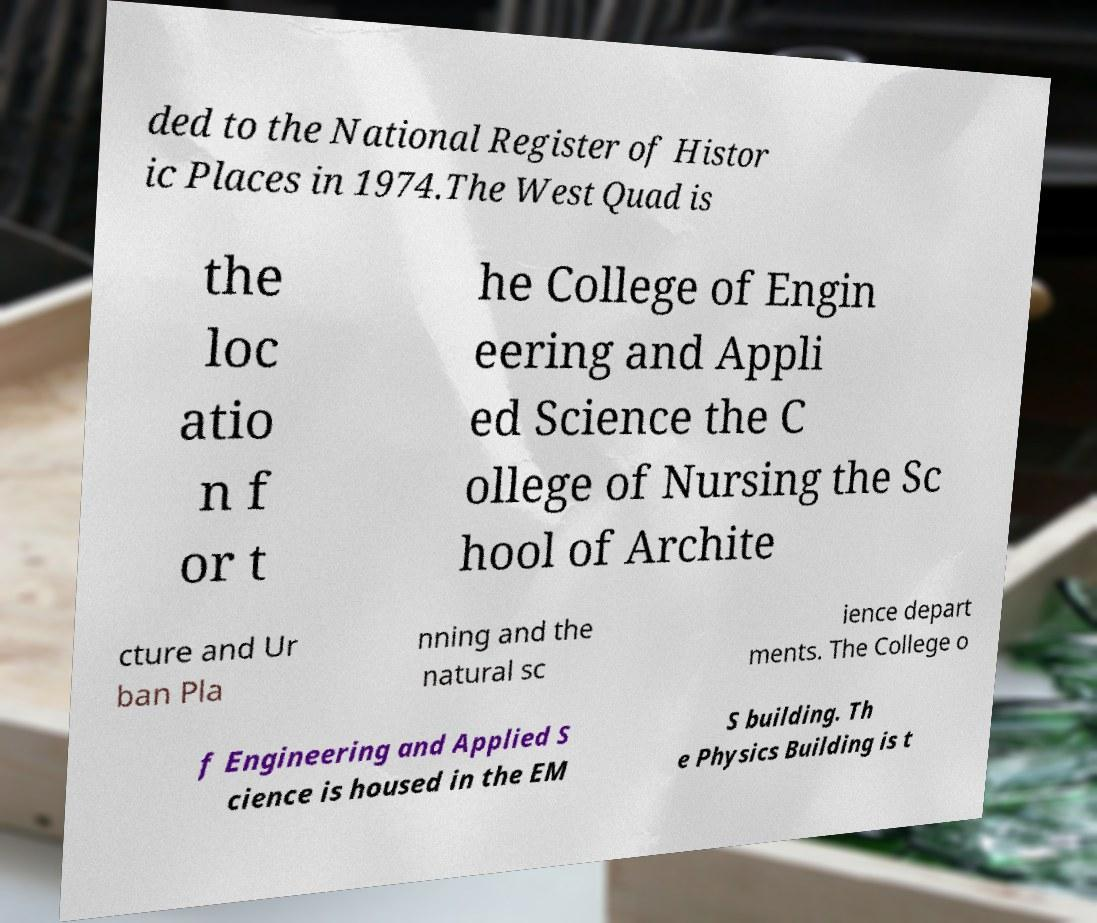For documentation purposes, I need the text within this image transcribed. Could you provide that? ded to the National Register of Histor ic Places in 1974.The West Quad is the loc atio n f or t he College of Engin eering and Appli ed Science the C ollege of Nursing the Sc hool of Archite cture and Ur ban Pla nning and the natural sc ience depart ments. The College o f Engineering and Applied S cience is housed in the EM S building. Th e Physics Building is t 